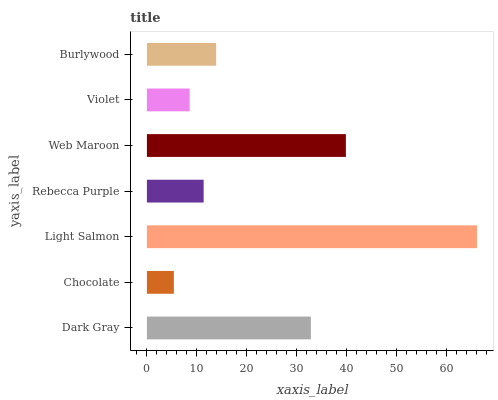Is Chocolate the minimum?
Answer yes or no. Yes. Is Light Salmon the maximum?
Answer yes or no. Yes. Is Light Salmon the minimum?
Answer yes or no. No. Is Chocolate the maximum?
Answer yes or no. No. Is Light Salmon greater than Chocolate?
Answer yes or no. Yes. Is Chocolate less than Light Salmon?
Answer yes or no. Yes. Is Chocolate greater than Light Salmon?
Answer yes or no. No. Is Light Salmon less than Chocolate?
Answer yes or no. No. Is Burlywood the high median?
Answer yes or no. Yes. Is Burlywood the low median?
Answer yes or no. Yes. Is Rebecca Purple the high median?
Answer yes or no. No. Is Web Maroon the low median?
Answer yes or no. No. 